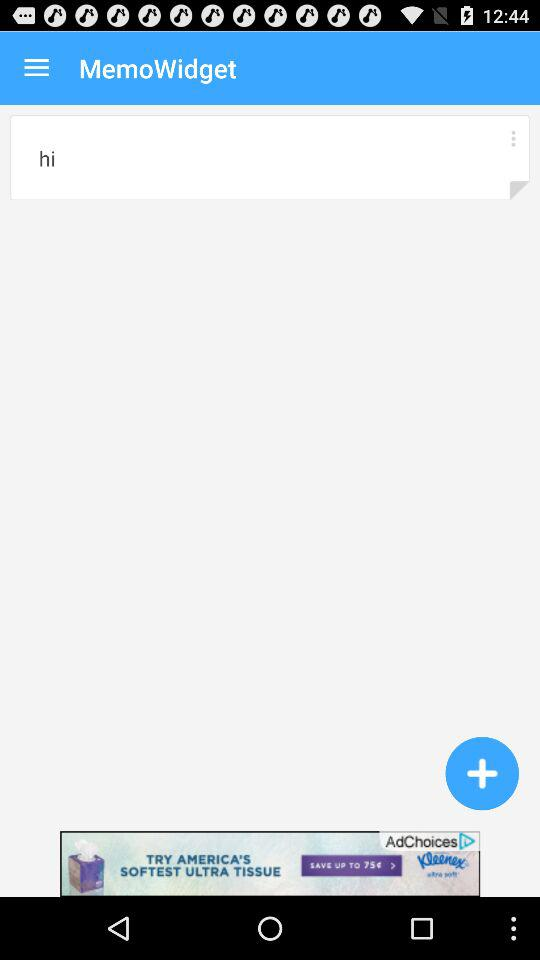Who is this application powered by?
When the provided information is insufficient, respond with <no answer>. <no answer> 